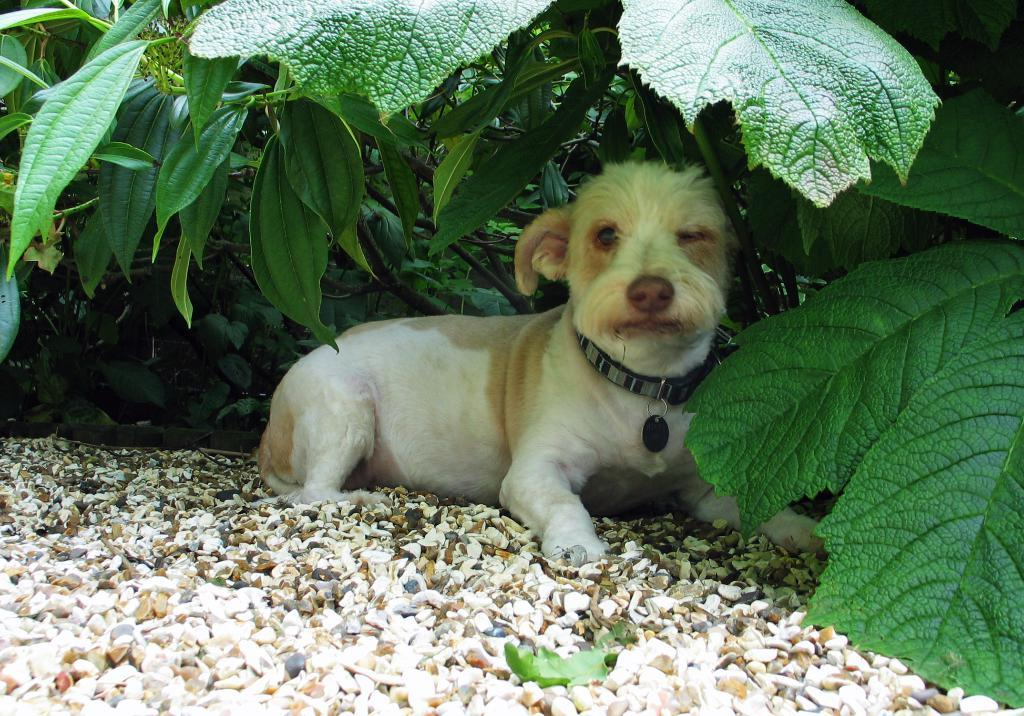What type of animal is in the image? There is a dog in the image. What is the dog wearing? The dog is wearing a dog belt. What can be seen at the bottom of the image? There are rocks at the bottom of the image. What type of vegetation is visible in the background? There are plants in the background of the image. What type of oatmeal is the dog eating in the image? There is no oatmeal present in the image; the dog is not eating anything. What observation can be made about the dog's behavior in the image? The image does not show the dog's behavior, so it is not possible to make any observations about it. 